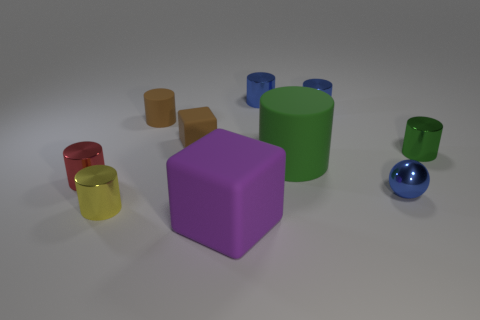Are there any repeating patterns or themes in the arrangement of objects? There is no apparent repeating pattern in the objects' arrangement; however, the grouping of similar shapes suggests an intentional theme based on geometry and color contrast. 